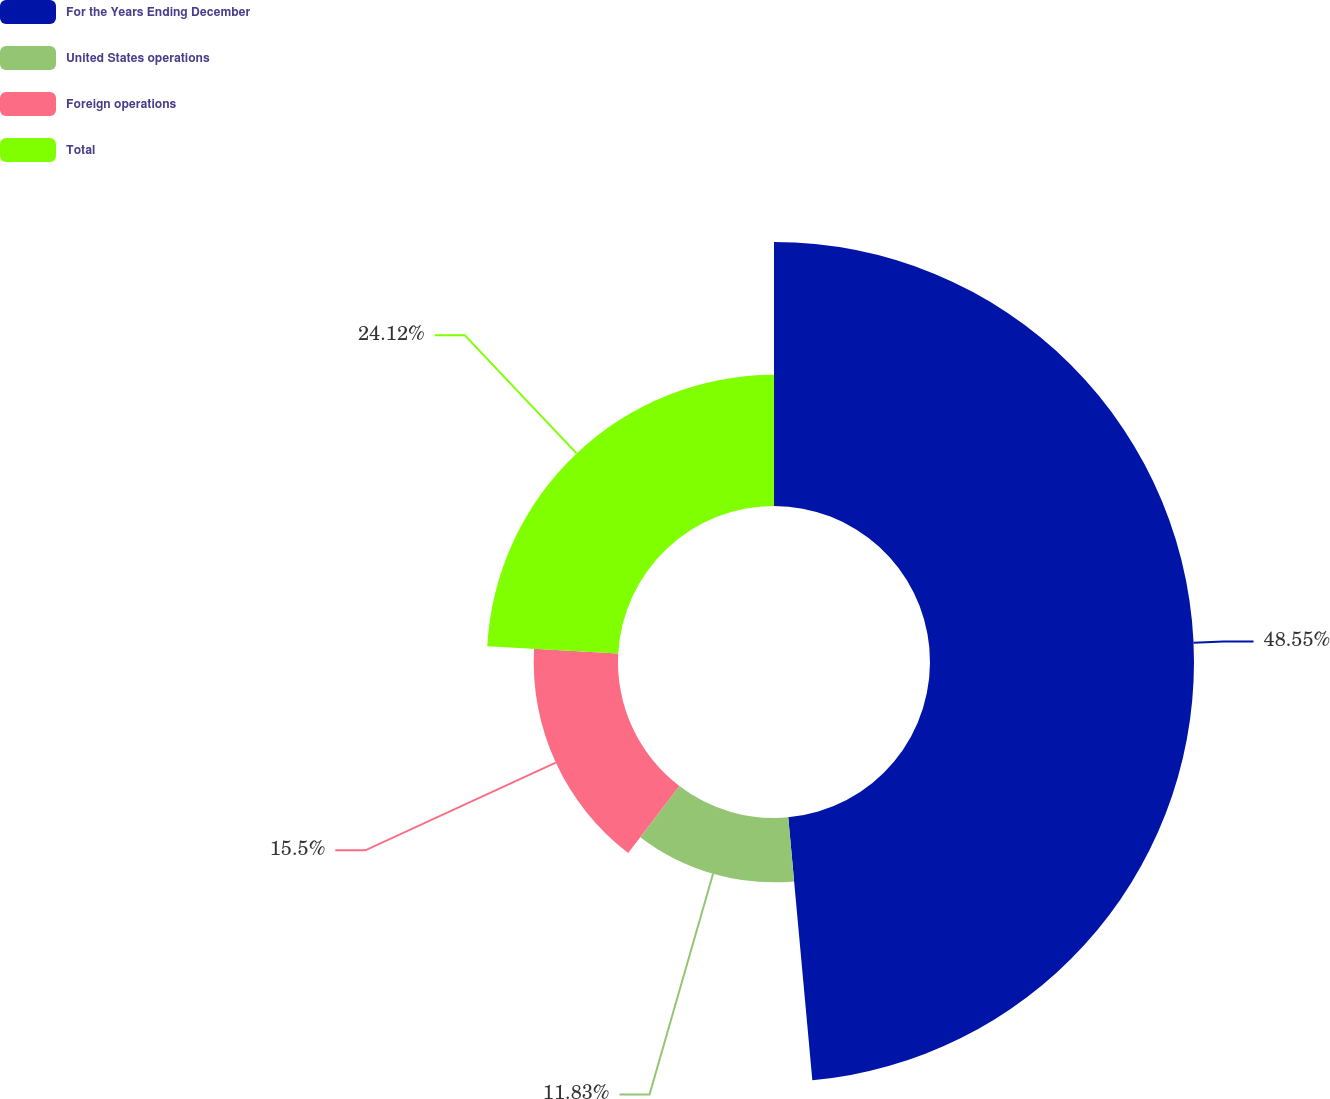Convert chart. <chart><loc_0><loc_0><loc_500><loc_500><pie_chart><fcel>For the Years Ending December<fcel>United States operations<fcel>Foreign operations<fcel>Total<nl><fcel>48.54%<fcel>11.83%<fcel>15.5%<fcel>24.12%<nl></chart> 